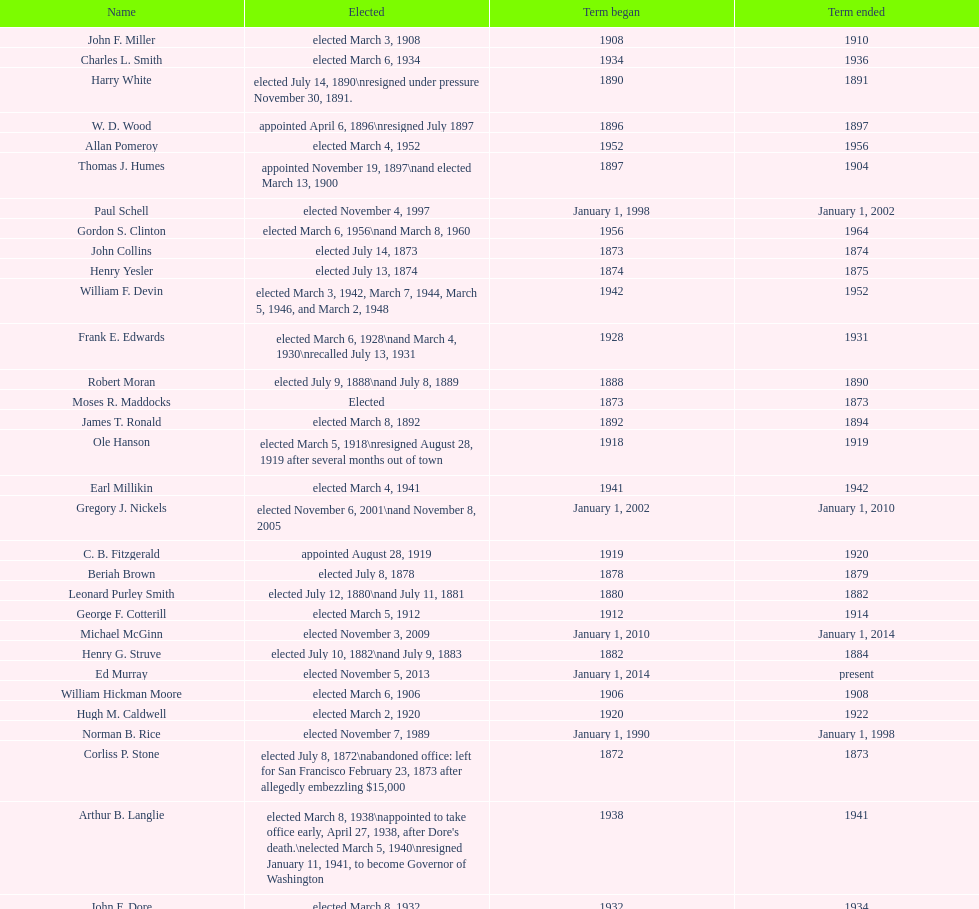Who began their term in 1890? Harry White. 